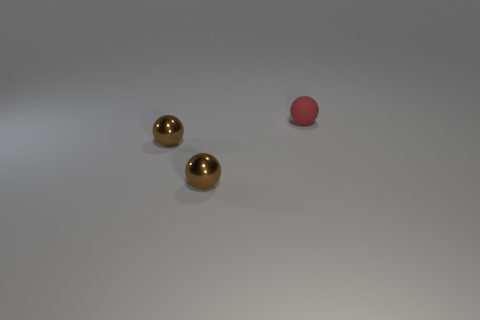Subtract all green spheres. Subtract all green cylinders. How many spheres are left? 3 Add 1 small red rubber cylinders. How many objects exist? 4 Add 3 red rubber spheres. How many red rubber spheres are left? 4 Add 2 small brown metallic things. How many small brown metallic things exist? 4 Subtract 0 gray blocks. How many objects are left? 3 Subtract all small cyan shiny balls. Subtract all tiny metal spheres. How many objects are left? 1 